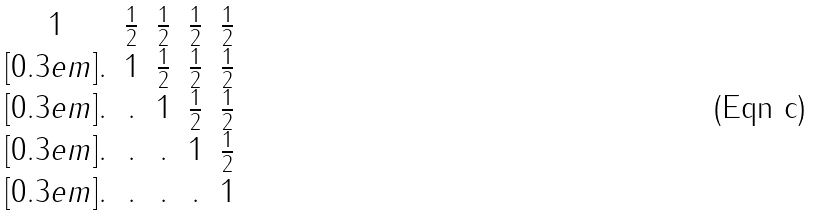<formula> <loc_0><loc_0><loc_500><loc_500>\begin{matrix} 1 & \frac { 1 } { 2 } & \frac { 1 } { 2 } & \frac { 1 } { 2 } & \frac { 1 } { 2 } \\ [ 0 . 3 e m ] . & 1 & \frac { 1 } { 2 } & \frac { 1 } { 2 } & \frac { 1 } { 2 } \\ [ 0 . 3 e m ] . & . & 1 & \frac { 1 } { 2 } & \frac { 1 } { 2 } \\ [ 0 . 3 e m ] . & . & . & 1 & \frac { 1 } { 2 } \\ [ 0 . 3 e m ] . & . & . & . & 1 \end{matrix}</formula> 